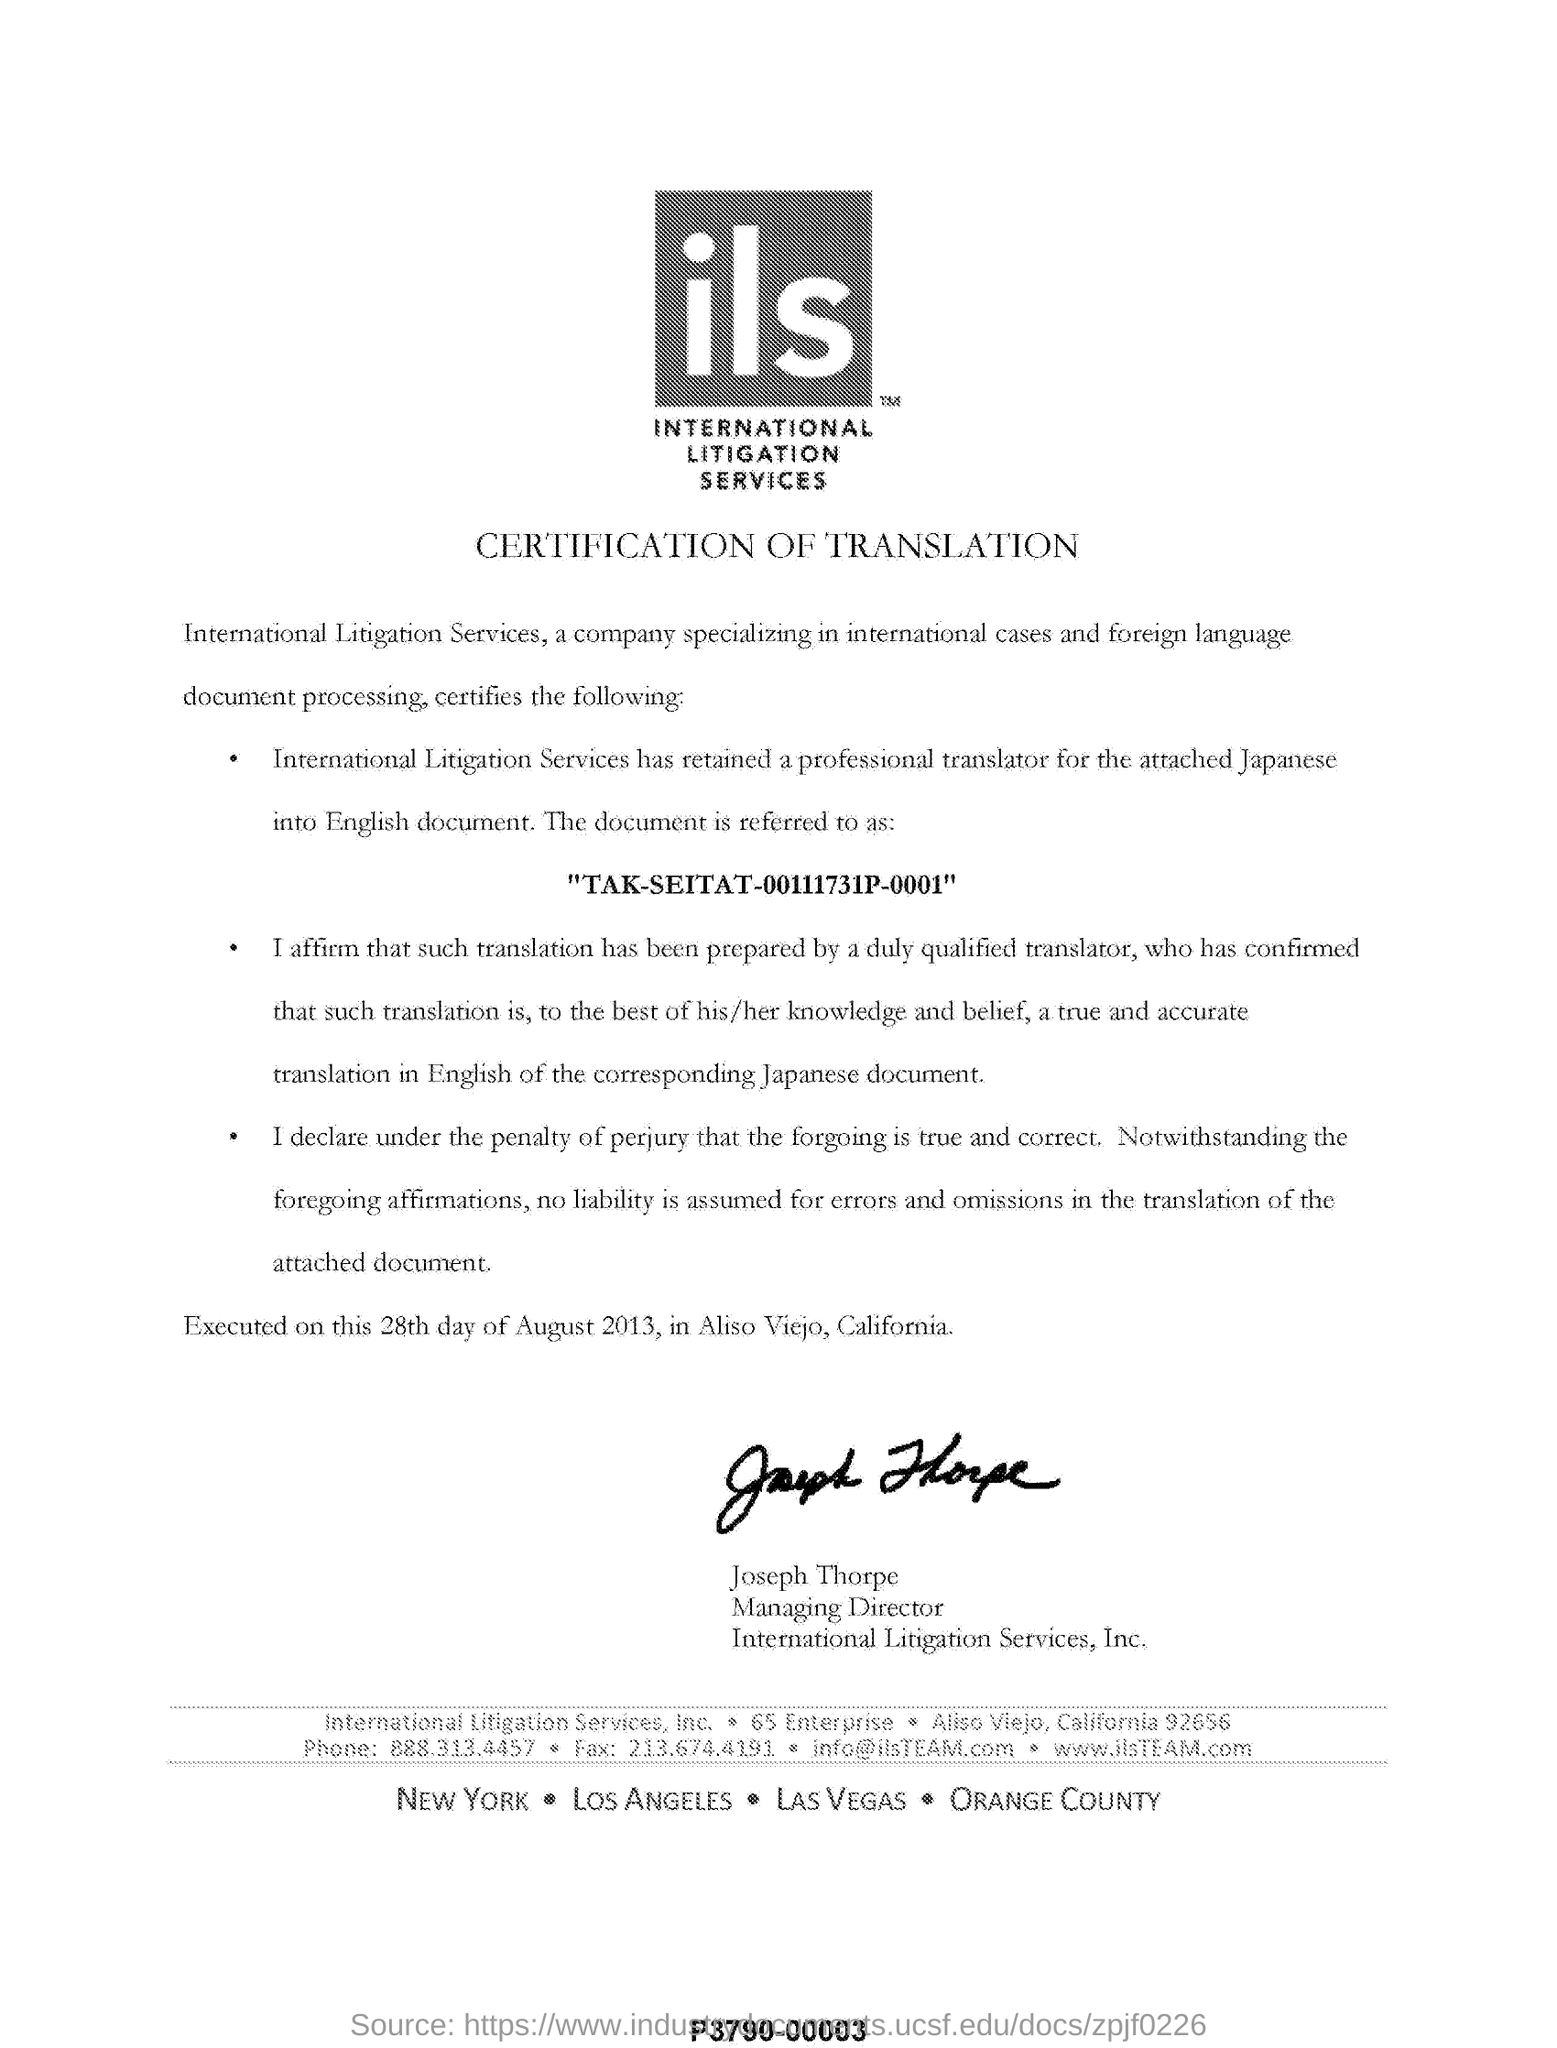Specify some key components in this picture. The translation was carried out in Aliso Viejo, California. Joseph Thorpe is the managing director of International Litigation Services. On August 28th, 2013, the execution took place. 